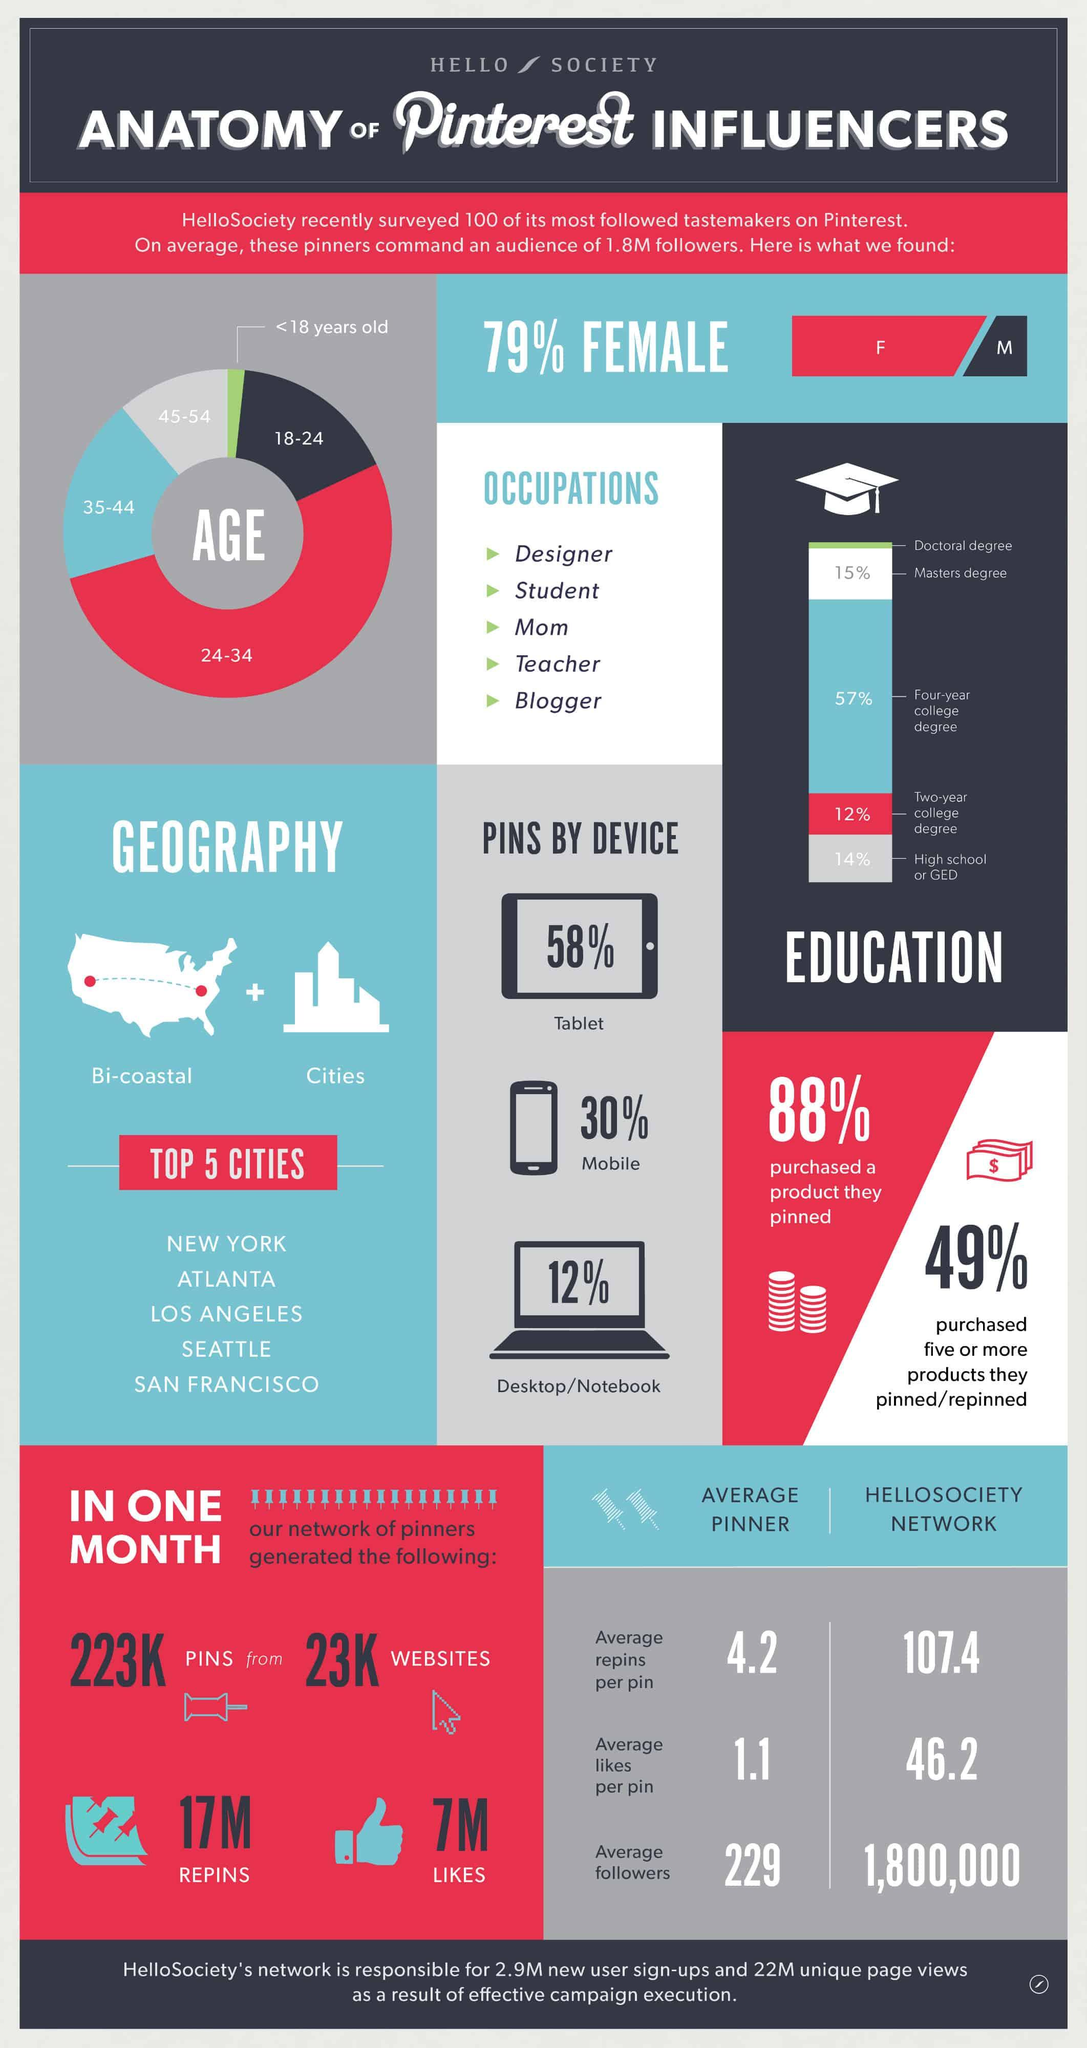Specify some key components in this picture. Approximately 12% of people do not purchase a product that they have pinned on their Pinterest account. According to the data, only 51% of people do not purchase five or more products that they have pinned or repinned. Around 12% of Pinners use Pins on their desktop or notebook computers. There are five different types of Pinner occupations listed. The 35-44 age group has the second highest number of audience. 